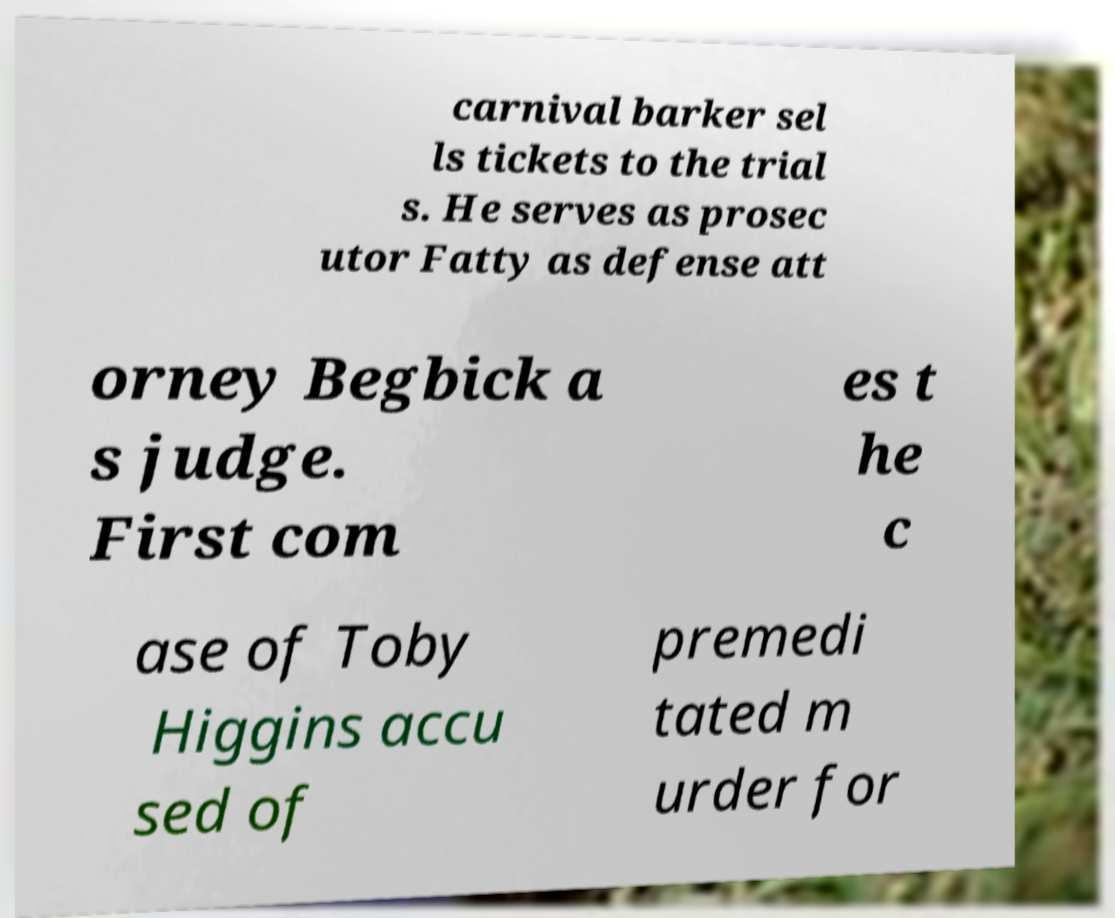Could you assist in decoding the text presented in this image and type it out clearly? carnival barker sel ls tickets to the trial s. He serves as prosec utor Fatty as defense att orney Begbick a s judge. First com es t he c ase of Toby Higgins accu sed of premedi tated m urder for 